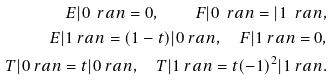Convert formula to latex. <formula><loc_0><loc_0><loc_500><loc_500>E | 0 \ r a n = 0 , \quad F | 0 \ r a n = | 1 \ r a n , \\ E | 1 \ r a n = ( 1 - t ) | 0 \ r a n , \quad F | 1 \ r a n = 0 , \\ T | 0 \ r a n = t | 0 \ r a n , \quad T | 1 \ r a n = t ( - 1 ) ^ { 2 } | 1 \ r a n .</formula> 